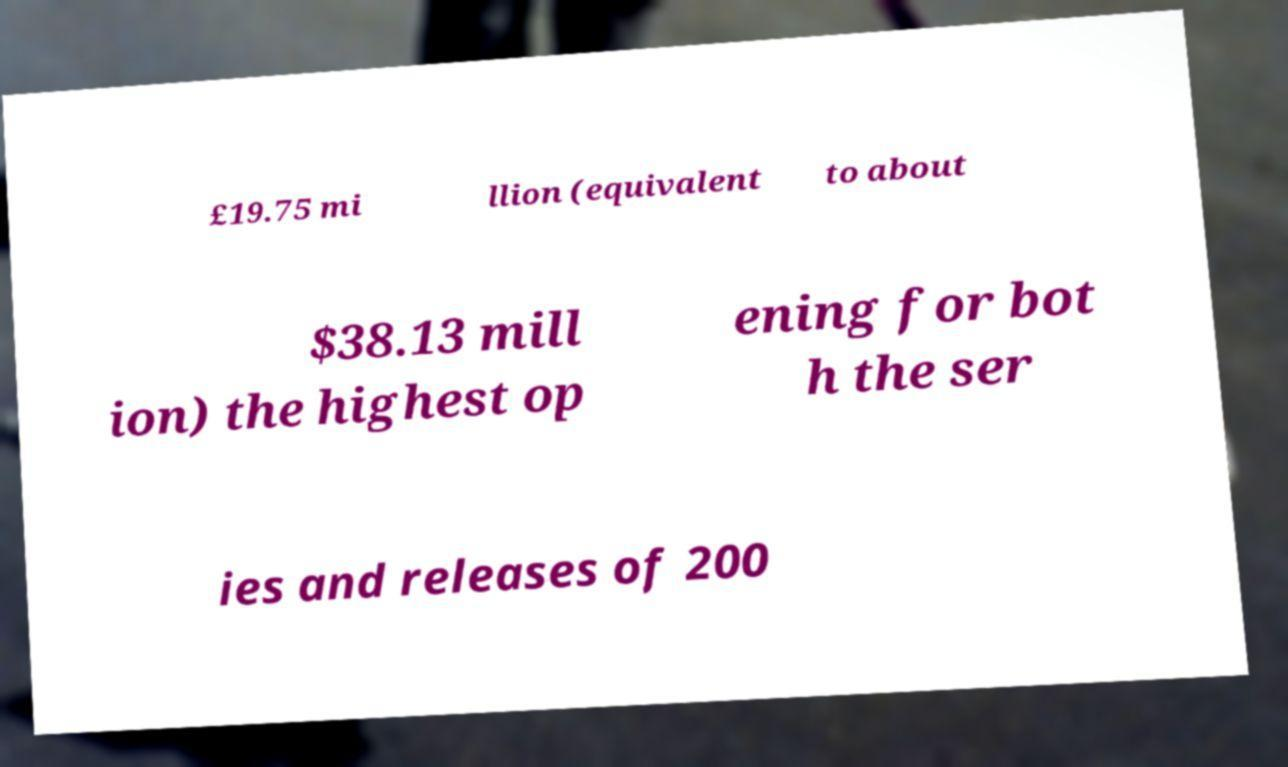I need the written content from this picture converted into text. Can you do that? £19.75 mi llion (equivalent to about $38.13 mill ion) the highest op ening for bot h the ser ies and releases of 200 